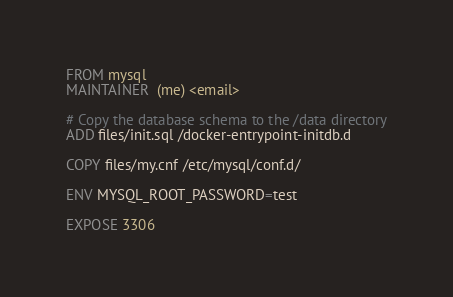<code> <loc_0><loc_0><loc_500><loc_500><_Dockerfile_>FROM mysql
MAINTAINER  (me) <email>

# Copy the database schema to the /data directory
ADD files/init.sql /docker-entrypoint-initdb.d

COPY files/my.cnf /etc/mysql/conf.d/

ENV MYSQL_ROOT_PASSWORD=test

EXPOSE 3306
</code> 